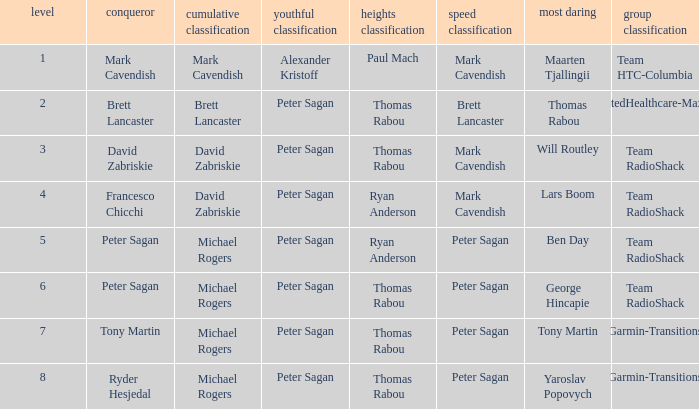When peter sagan clinched the youth classification and thomas rabou succeeded in the most audacious, who took the win in the sprint classification? Brett Lancaster. 